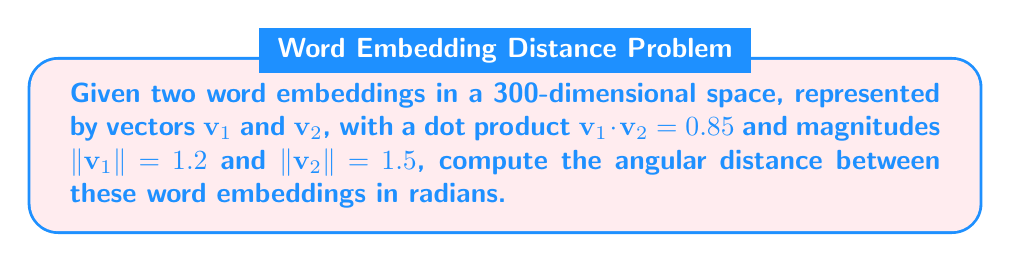What is the answer to this math problem? To solve this problem, we'll use the cosine similarity formula and then convert it to an angle. This is relevant to AI and language processing as it allows us to quantify the semantic similarity between words in a high-dimensional space.

1) The cosine similarity between two vectors is given by:

   $$\cos \theta = \frac{\mathbf{v}_1 \cdot \mathbf{v}_2}{\|\mathbf{v}_1\| \|\mathbf{v}_2\|}$$

2) We're given:
   $\mathbf{v}_1 \cdot \mathbf{v}_2 = 0.85$
   $\|\mathbf{v}_1\| = 1.2$
   $\|\mathbf{v}_2\| = 1.5$

3) Substituting these values:

   $$\cos \theta = \frac{0.85}{1.2 \times 1.5} = \frac{0.85}{1.8} \approx 0.4722$$

4) To find the angle $\theta$, we need to take the inverse cosine (arccos):

   $$\theta = \arccos(0.4722)$$

5) Using a calculator or programming function:

   $$\theta \approx 1.0903 \text{ radians}$$

This angle represents the angular distance between the word embeddings in the high-dimensional space.
Answer: The angular distance between the word embeddings is approximately 1.0903 radians. 